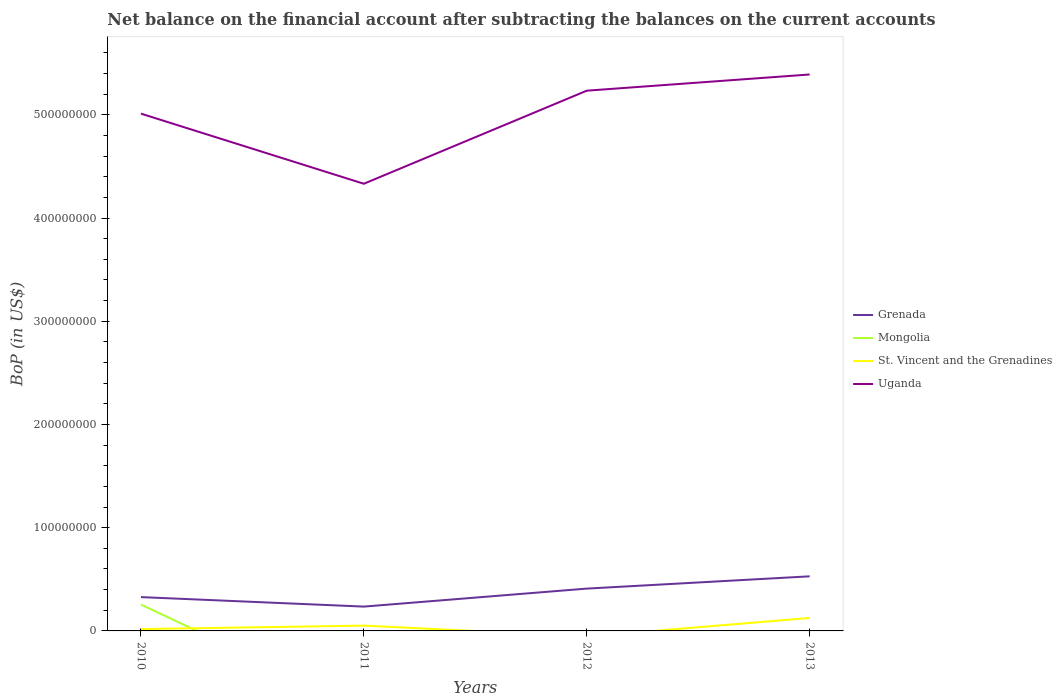How many different coloured lines are there?
Give a very brief answer. 4. Does the line corresponding to Mongolia intersect with the line corresponding to Uganda?
Ensure brevity in your answer.  No. Is the number of lines equal to the number of legend labels?
Give a very brief answer. No. Across all years, what is the maximum Balance of Payments in St. Vincent and the Grenadines?
Your answer should be compact. 0. What is the total Balance of Payments in Uganda in the graph?
Keep it short and to the point. -9.02e+07. What is the difference between the highest and the second highest Balance of Payments in Grenada?
Your response must be concise. 2.93e+07. What is the difference between the highest and the lowest Balance of Payments in Mongolia?
Give a very brief answer. 1. Is the Balance of Payments in Grenada strictly greater than the Balance of Payments in St. Vincent and the Grenadines over the years?
Your answer should be compact. No. Does the graph contain any zero values?
Give a very brief answer. Yes. Where does the legend appear in the graph?
Give a very brief answer. Center right. How are the legend labels stacked?
Your answer should be very brief. Vertical. What is the title of the graph?
Your answer should be very brief. Net balance on the financial account after subtracting the balances on the current accounts. What is the label or title of the Y-axis?
Provide a succinct answer. BoP (in US$). What is the BoP (in US$) of Grenada in 2010?
Offer a very short reply. 3.28e+07. What is the BoP (in US$) of Mongolia in 2010?
Offer a terse response. 2.55e+07. What is the BoP (in US$) in St. Vincent and the Grenadines in 2010?
Ensure brevity in your answer.  1.79e+06. What is the BoP (in US$) of Uganda in 2010?
Give a very brief answer. 5.01e+08. What is the BoP (in US$) in Grenada in 2011?
Provide a succinct answer. 2.36e+07. What is the BoP (in US$) in Mongolia in 2011?
Offer a terse response. 0. What is the BoP (in US$) of St. Vincent and the Grenadines in 2011?
Your response must be concise. 5.15e+06. What is the BoP (in US$) of Uganda in 2011?
Give a very brief answer. 4.33e+08. What is the BoP (in US$) of Grenada in 2012?
Keep it short and to the point. 4.10e+07. What is the BoP (in US$) in Uganda in 2012?
Your answer should be compact. 5.23e+08. What is the BoP (in US$) in Grenada in 2013?
Your answer should be compact. 5.29e+07. What is the BoP (in US$) in Mongolia in 2013?
Make the answer very short. 0. What is the BoP (in US$) in St. Vincent and the Grenadines in 2013?
Your answer should be compact. 1.26e+07. What is the BoP (in US$) in Uganda in 2013?
Your answer should be compact. 5.39e+08. Across all years, what is the maximum BoP (in US$) in Grenada?
Give a very brief answer. 5.29e+07. Across all years, what is the maximum BoP (in US$) in Mongolia?
Ensure brevity in your answer.  2.55e+07. Across all years, what is the maximum BoP (in US$) in St. Vincent and the Grenadines?
Your response must be concise. 1.26e+07. Across all years, what is the maximum BoP (in US$) of Uganda?
Offer a very short reply. 5.39e+08. Across all years, what is the minimum BoP (in US$) in Grenada?
Your answer should be very brief. 2.36e+07. Across all years, what is the minimum BoP (in US$) of Mongolia?
Give a very brief answer. 0. Across all years, what is the minimum BoP (in US$) of St. Vincent and the Grenadines?
Your response must be concise. 0. Across all years, what is the minimum BoP (in US$) of Uganda?
Offer a terse response. 4.33e+08. What is the total BoP (in US$) of Grenada in the graph?
Your answer should be compact. 1.50e+08. What is the total BoP (in US$) in Mongolia in the graph?
Offer a very short reply. 2.55e+07. What is the total BoP (in US$) in St. Vincent and the Grenadines in the graph?
Offer a very short reply. 1.95e+07. What is the total BoP (in US$) of Uganda in the graph?
Provide a short and direct response. 2.00e+09. What is the difference between the BoP (in US$) of Grenada in 2010 and that in 2011?
Offer a very short reply. 9.20e+06. What is the difference between the BoP (in US$) in St. Vincent and the Grenadines in 2010 and that in 2011?
Provide a succinct answer. -3.36e+06. What is the difference between the BoP (in US$) of Uganda in 2010 and that in 2011?
Ensure brevity in your answer.  6.79e+07. What is the difference between the BoP (in US$) in Grenada in 2010 and that in 2012?
Your response must be concise. -8.23e+06. What is the difference between the BoP (in US$) of Uganda in 2010 and that in 2012?
Your response must be concise. -2.22e+07. What is the difference between the BoP (in US$) in Grenada in 2010 and that in 2013?
Keep it short and to the point. -2.01e+07. What is the difference between the BoP (in US$) of St. Vincent and the Grenadines in 2010 and that in 2013?
Provide a succinct answer. -1.08e+07. What is the difference between the BoP (in US$) in Uganda in 2010 and that in 2013?
Keep it short and to the point. -3.79e+07. What is the difference between the BoP (in US$) in Grenada in 2011 and that in 2012?
Offer a terse response. -1.74e+07. What is the difference between the BoP (in US$) of Uganda in 2011 and that in 2012?
Provide a short and direct response. -9.02e+07. What is the difference between the BoP (in US$) of Grenada in 2011 and that in 2013?
Give a very brief answer. -2.93e+07. What is the difference between the BoP (in US$) in St. Vincent and the Grenadines in 2011 and that in 2013?
Provide a short and direct response. -7.40e+06. What is the difference between the BoP (in US$) of Uganda in 2011 and that in 2013?
Offer a very short reply. -1.06e+08. What is the difference between the BoP (in US$) in Grenada in 2012 and that in 2013?
Provide a short and direct response. -1.19e+07. What is the difference between the BoP (in US$) in Uganda in 2012 and that in 2013?
Offer a very short reply. -1.57e+07. What is the difference between the BoP (in US$) in Grenada in 2010 and the BoP (in US$) in St. Vincent and the Grenadines in 2011?
Provide a succinct answer. 2.76e+07. What is the difference between the BoP (in US$) in Grenada in 2010 and the BoP (in US$) in Uganda in 2011?
Your response must be concise. -4.00e+08. What is the difference between the BoP (in US$) in Mongolia in 2010 and the BoP (in US$) in St. Vincent and the Grenadines in 2011?
Your response must be concise. 2.04e+07. What is the difference between the BoP (in US$) of Mongolia in 2010 and the BoP (in US$) of Uganda in 2011?
Give a very brief answer. -4.08e+08. What is the difference between the BoP (in US$) in St. Vincent and the Grenadines in 2010 and the BoP (in US$) in Uganda in 2011?
Offer a terse response. -4.31e+08. What is the difference between the BoP (in US$) of Grenada in 2010 and the BoP (in US$) of Uganda in 2012?
Keep it short and to the point. -4.91e+08. What is the difference between the BoP (in US$) in Mongolia in 2010 and the BoP (in US$) in Uganda in 2012?
Provide a succinct answer. -4.98e+08. What is the difference between the BoP (in US$) of St. Vincent and the Grenadines in 2010 and the BoP (in US$) of Uganda in 2012?
Give a very brief answer. -5.22e+08. What is the difference between the BoP (in US$) in Grenada in 2010 and the BoP (in US$) in St. Vincent and the Grenadines in 2013?
Your answer should be compact. 2.02e+07. What is the difference between the BoP (in US$) of Grenada in 2010 and the BoP (in US$) of Uganda in 2013?
Give a very brief answer. -5.06e+08. What is the difference between the BoP (in US$) in Mongolia in 2010 and the BoP (in US$) in St. Vincent and the Grenadines in 2013?
Make the answer very short. 1.30e+07. What is the difference between the BoP (in US$) of Mongolia in 2010 and the BoP (in US$) of Uganda in 2013?
Provide a short and direct response. -5.14e+08. What is the difference between the BoP (in US$) in St. Vincent and the Grenadines in 2010 and the BoP (in US$) in Uganda in 2013?
Keep it short and to the point. -5.37e+08. What is the difference between the BoP (in US$) in Grenada in 2011 and the BoP (in US$) in Uganda in 2012?
Make the answer very short. -5.00e+08. What is the difference between the BoP (in US$) in St. Vincent and the Grenadines in 2011 and the BoP (in US$) in Uganda in 2012?
Make the answer very short. -5.18e+08. What is the difference between the BoP (in US$) of Grenada in 2011 and the BoP (in US$) of St. Vincent and the Grenadines in 2013?
Your answer should be compact. 1.10e+07. What is the difference between the BoP (in US$) of Grenada in 2011 and the BoP (in US$) of Uganda in 2013?
Ensure brevity in your answer.  -5.16e+08. What is the difference between the BoP (in US$) of St. Vincent and the Grenadines in 2011 and the BoP (in US$) of Uganda in 2013?
Make the answer very short. -5.34e+08. What is the difference between the BoP (in US$) in Grenada in 2012 and the BoP (in US$) in St. Vincent and the Grenadines in 2013?
Give a very brief answer. 2.84e+07. What is the difference between the BoP (in US$) in Grenada in 2012 and the BoP (in US$) in Uganda in 2013?
Your answer should be compact. -4.98e+08. What is the average BoP (in US$) of Grenada per year?
Ensure brevity in your answer.  3.76e+07. What is the average BoP (in US$) of Mongolia per year?
Offer a very short reply. 6.38e+06. What is the average BoP (in US$) in St. Vincent and the Grenadines per year?
Provide a short and direct response. 4.87e+06. What is the average BoP (in US$) of Uganda per year?
Offer a terse response. 4.99e+08. In the year 2010, what is the difference between the BoP (in US$) of Grenada and BoP (in US$) of Mongolia?
Make the answer very short. 7.23e+06. In the year 2010, what is the difference between the BoP (in US$) in Grenada and BoP (in US$) in St. Vincent and the Grenadines?
Your answer should be very brief. 3.10e+07. In the year 2010, what is the difference between the BoP (in US$) in Grenada and BoP (in US$) in Uganda?
Your response must be concise. -4.68e+08. In the year 2010, what is the difference between the BoP (in US$) in Mongolia and BoP (in US$) in St. Vincent and the Grenadines?
Make the answer very short. 2.37e+07. In the year 2010, what is the difference between the BoP (in US$) in Mongolia and BoP (in US$) in Uganda?
Offer a very short reply. -4.76e+08. In the year 2010, what is the difference between the BoP (in US$) in St. Vincent and the Grenadines and BoP (in US$) in Uganda?
Make the answer very short. -4.99e+08. In the year 2011, what is the difference between the BoP (in US$) of Grenada and BoP (in US$) of St. Vincent and the Grenadines?
Make the answer very short. 1.84e+07. In the year 2011, what is the difference between the BoP (in US$) of Grenada and BoP (in US$) of Uganda?
Provide a succinct answer. -4.10e+08. In the year 2011, what is the difference between the BoP (in US$) in St. Vincent and the Grenadines and BoP (in US$) in Uganda?
Ensure brevity in your answer.  -4.28e+08. In the year 2012, what is the difference between the BoP (in US$) of Grenada and BoP (in US$) of Uganda?
Keep it short and to the point. -4.82e+08. In the year 2013, what is the difference between the BoP (in US$) of Grenada and BoP (in US$) of St. Vincent and the Grenadines?
Offer a very short reply. 4.03e+07. In the year 2013, what is the difference between the BoP (in US$) of Grenada and BoP (in US$) of Uganda?
Your response must be concise. -4.86e+08. In the year 2013, what is the difference between the BoP (in US$) in St. Vincent and the Grenadines and BoP (in US$) in Uganda?
Offer a very short reply. -5.27e+08. What is the ratio of the BoP (in US$) of Grenada in 2010 to that in 2011?
Your response must be concise. 1.39. What is the ratio of the BoP (in US$) of St. Vincent and the Grenadines in 2010 to that in 2011?
Your answer should be compact. 0.35. What is the ratio of the BoP (in US$) in Uganda in 2010 to that in 2011?
Give a very brief answer. 1.16. What is the ratio of the BoP (in US$) of Grenada in 2010 to that in 2012?
Offer a very short reply. 0.8. What is the ratio of the BoP (in US$) in Uganda in 2010 to that in 2012?
Your answer should be very brief. 0.96. What is the ratio of the BoP (in US$) of Grenada in 2010 to that in 2013?
Provide a short and direct response. 0.62. What is the ratio of the BoP (in US$) in St. Vincent and the Grenadines in 2010 to that in 2013?
Your answer should be compact. 0.14. What is the ratio of the BoP (in US$) of Uganda in 2010 to that in 2013?
Make the answer very short. 0.93. What is the ratio of the BoP (in US$) of Grenada in 2011 to that in 2012?
Give a very brief answer. 0.57. What is the ratio of the BoP (in US$) in Uganda in 2011 to that in 2012?
Provide a succinct answer. 0.83. What is the ratio of the BoP (in US$) in Grenada in 2011 to that in 2013?
Offer a terse response. 0.45. What is the ratio of the BoP (in US$) in St. Vincent and the Grenadines in 2011 to that in 2013?
Offer a very short reply. 0.41. What is the ratio of the BoP (in US$) in Uganda in 2011 to that in 2013?
Give a very brief answer. 0.8. What is the ratio of the BoP (in US$) in Grenada in 2012 to that in 2013?
Ensure brevity in your answer.  0.78. What is the ratio of the BoP (in US$) in Uganda in 2012 to that in 2013?
Make the answer very short. 0.97. What is the difference between the highest and the second highest BoP (in US$) in Grenada?
Ensure brevity in your answer.  1.19e+07. What is the difference between the highest and the second highest BoP (in US$) in St. Vincent and the Grenadines?
Provide a short and direct response. 7.40e+06. What is the difference between the highest and the second highest BoP (in US$) of Uganda?
Your answer should be very brief. 1.57e+07. What is the difference between the highest and the lowest BoP (in US$) in Grenada?
Provide a succinct answer. 2.93e+07. What is the difference between the highest and the lowest BoP (in US$) in Mongolia?
Your answer should be compact. 2.55e+07. What is the difference between the highest and the lowest BoP (in US$) of St. Vincent and the Grenadines?
Your response must be concise. 1.26e+07. What is the difference between the highest and the lowest BoP (in US$) in Uganda?
Keep it short and to the point. 1.06e+08. 